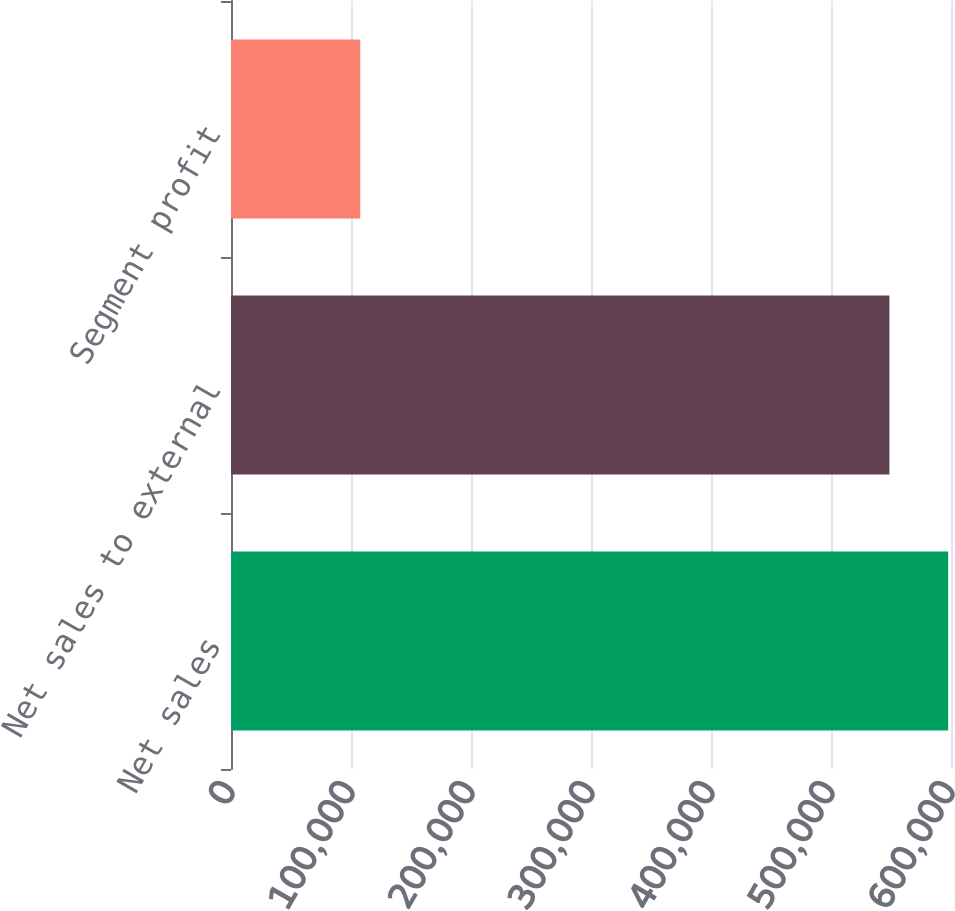<chart> <loc_0><loc_0><loc_500><loc_500><bar_chart><fcel>Net sales<fcel>Net sales to external<fcel>Segment profit<nl><fcel>597622<fcel>548677<fcel>107719<nl></chart> 